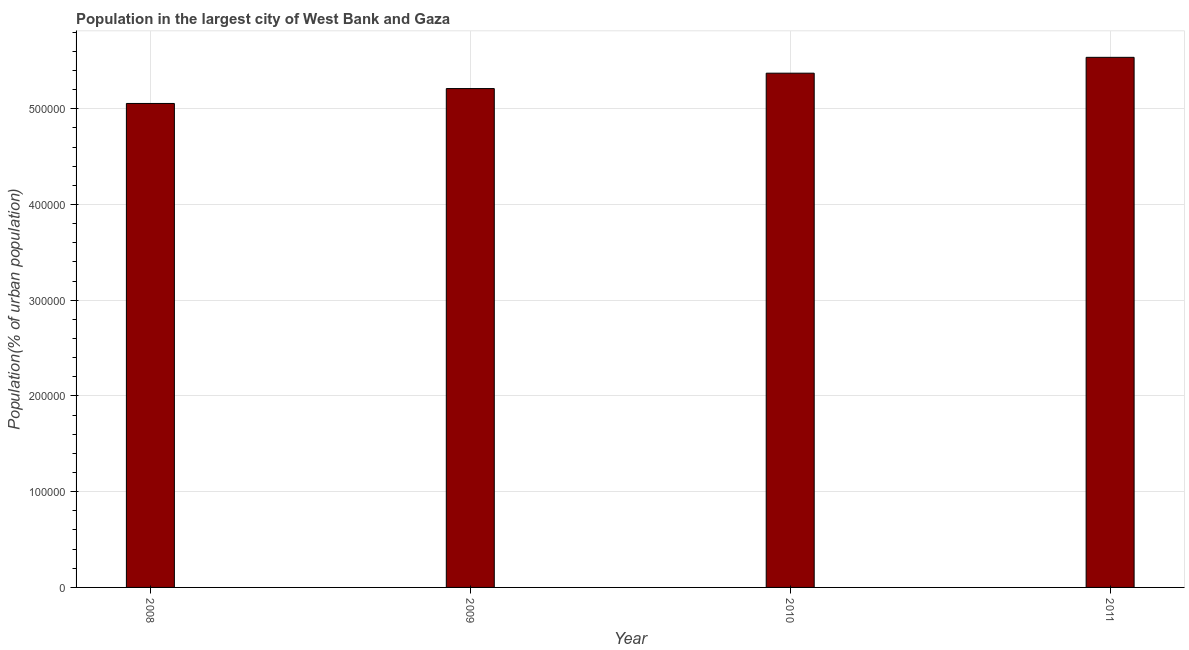Does the graph contain grids?
Offer a terse response. Yes. What is the title of the graph?
Give a very brief answer. Population in the largest city of West Bank and Gaza. What is the label or title of the Y-axis?
Make the answer very short. Population(% of urban population). What is the population in largest city in 2011?
Your answer should be compact. 5.54e+05. Across all years, what is the maximum population in largest city?
Provide a succinct answer. 5.54e+05. Across all years, what is the minimum population in largest city?
Offer a terse response. 5.06e+05. In which year was the population in largest city maximum?
Keep it short and to the point. 2011. What is the sum of the population in largest city?
Give a very brief answer. 2.12e+06. What is the difference between the population in largest city in 2010 and 2011?
Give a very brief answer. -1.66e+04. What is the average population in largest city per year?
Make the answer very short. 5.29e+05. What is the median population in largest city?
Give a very brief answer. 5.29e+05. In how many years, is the population in largest city greater than 520000 %?
Give a very brief answer. 3. What is the difference between the highest and the second highest population in largest city?
Offer a terse response. 1.66e+04. What is the difference between the highest and the lowest population in largest city?
Offer a terse response. 4.82e+04. In how many years, is the population in largest city greater than the average population in largest city taken over all years?
Ensure brevity in your answer.  2. Are all the bars in the graph horizontal?
Keep it short and to the point. No. How many years are there in the graph?
Make the answer very short. 4. Are the values on the major ticks of Y-axis written in scientific E-notation?
Keep it short and to the point. No. What is the Population(% of urban population) of 2008?
Keep it short and to the point. 5.06e+05. What is the Population(% of urban population) in 2009?
Give a very brief answer. 5.21e+05. What is the Population(% of urban population) of 2010?
Give a very brief answer. 5.37e+05. What is the Population(% of urban population) in 2011?
Provide a short and direct response. 5.54e+05. What is the difference between the Population(% of urban population) in 2008 and 2009?
Make the answer very short. -1.56e+04. What is the difference between the Population(% of urban population) in 2008 and 2010?
Provide a succinct answer. -3.16e+04. What is the difference between the Population(% of urban population) in 2008 and 2011?
Your answer should be compact. -4.82e+04. What is the difference between the Population(% of urban population) in 2009 and 2010?
Keep it short and to the point. -1.61e+04. What is the difference between the Population(% of urban population) in 2009 and 2011?
Your response must be concise. -3.26e+04. What is the difference between the Population(% of urban population) in 2010 and 2011?
Offer a very short reply. -1.66e+04. What is the ratio of the Population(% of urban population) in 2008 to that in 2009?
Your response must be concise. 0.97. What is the ratio of the Population(% of urban population) in 2008 to that in 2010?
Your answer should be very brief. 0.94. What is the ratio of the Population(% of urban population) in 2009 to that in 2010?
Provide a succinct answer. 0.97. What is the ratio of the Population(% of urban population) in 2009 to that in 2011?
Your answer should be compact. 0.94. 